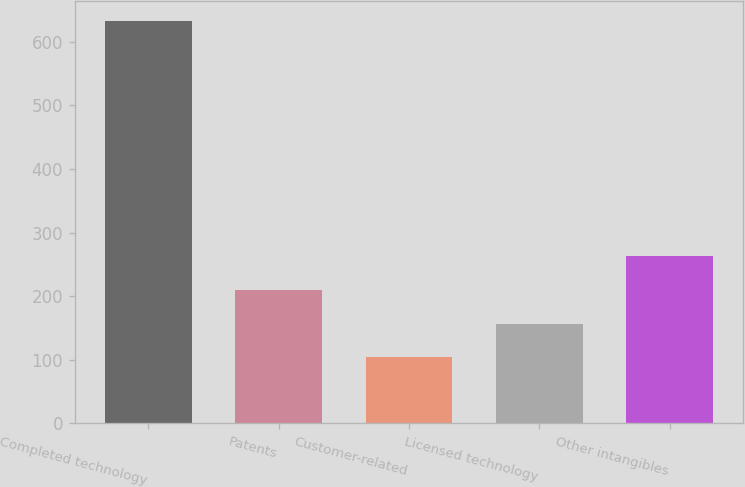Convert chart to OTSL. <chart><loc_0><loc_0><loc_500><loc_500><bar_chart><fcel>Completed technology<fcel>Patents<fcel>Customer-related<fcel>Licensed technology<fcel>Other intangibles<nl><fcel>633<fcel>209.8<fcel>104<fcel>156.9<fcel>262.7<nl></chart> 